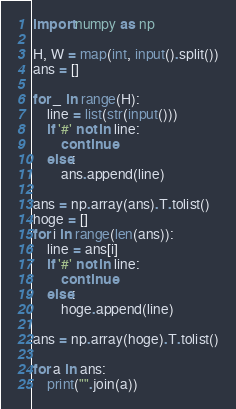<code> <loc_0><loc_0><loc_500><loc_500><_Python_>import numpy as np

H, W = map(int, input().split())
ans = []

for _ in range(H):
    line = list(str(input()))
    if '#' not in line:
        continue
    else:
        ans.append(line)

ans = np.array(ans).T.tolist()
hoge = []
for i in range(len(ans)):
    line = ans[i]
    if '#' not in line:
        continue
    else:
        hoge.append(line)

ans = np.array(hoge).T.tolist()

for a in ans:
    print("".join(a))
</code> 